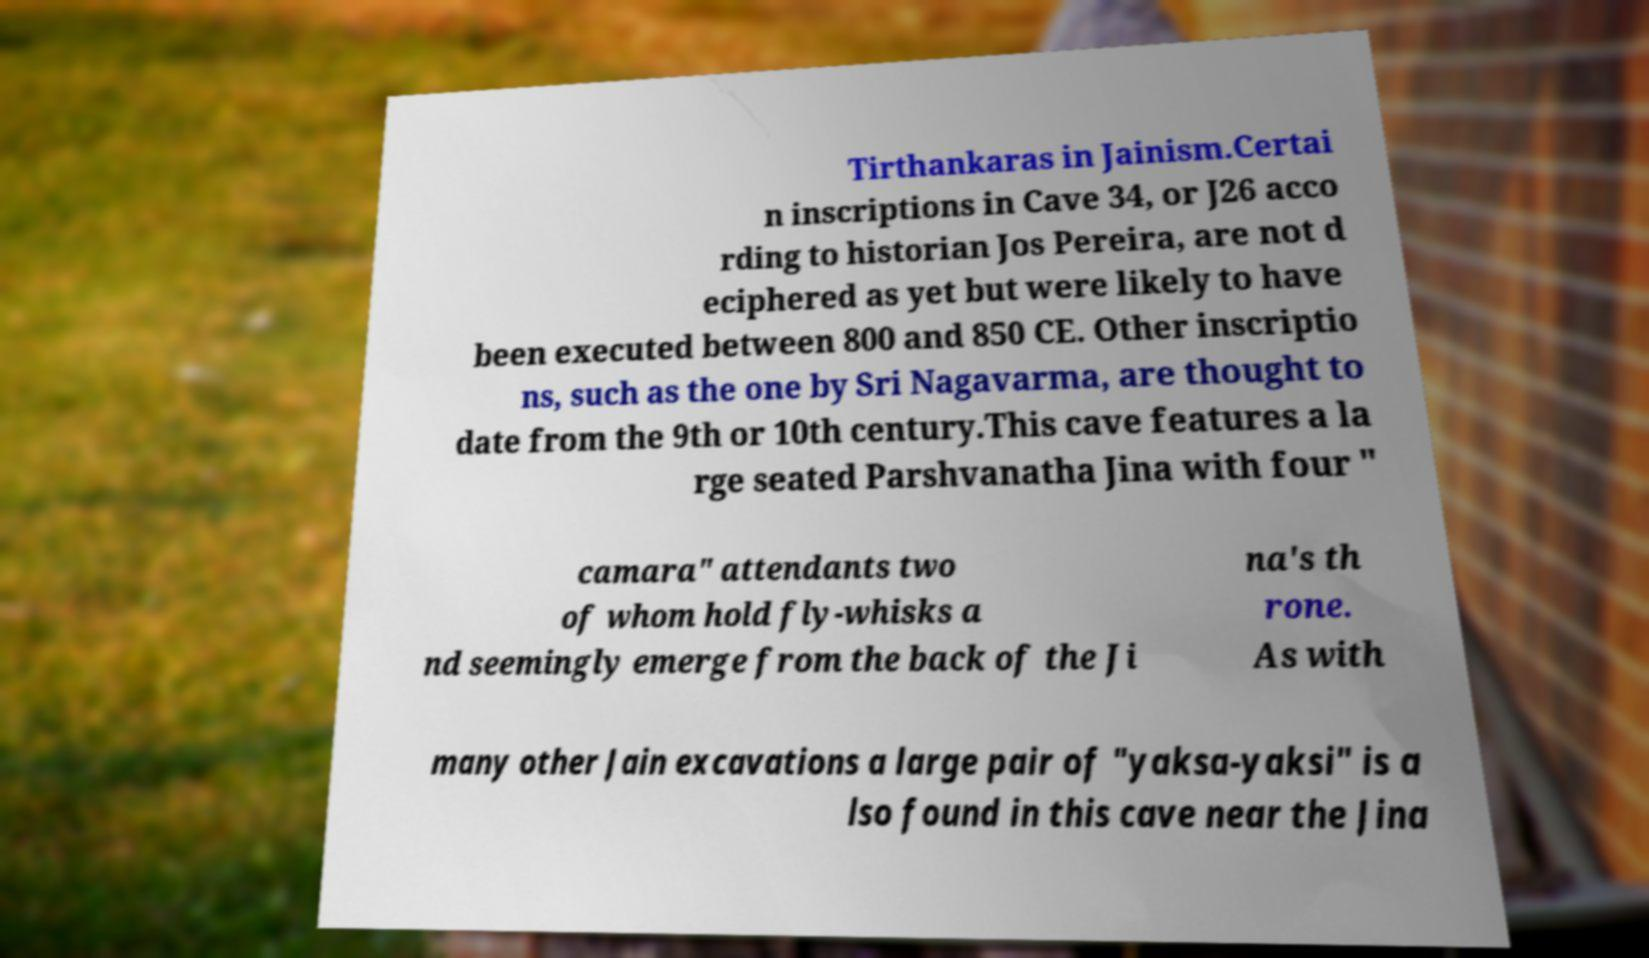There's text embedded in this image that I need extracted. Can you transcribe it verbatim? Tirthankaras in Jainism.Certai n inscriptions in Cave 34, or J26 acco rding to historian Jos Pereira, are not d eciphered as yet but were likely to have been executed between 800 and 850 CE. Other inscriptio ns, such as the one by Sri Nagavarma, are thought to date from the 9th or 10th century.This cave features a la rge seated Parshvanatha Jina with four " camara" attendants two of whom hold fly-whisks a nd seemingly emerge from the back of the Ji na's th rone. As with many other Jain excavations a large pair of "yaksa-yaksi" is a lso found in this cave near the Jina 